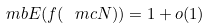<formula> <loc_0><loc_0><loc_500><loc_500>\ m b { E } ( f ( \ m c { N } ) ) = 1 + o ( 1 )</formula> 